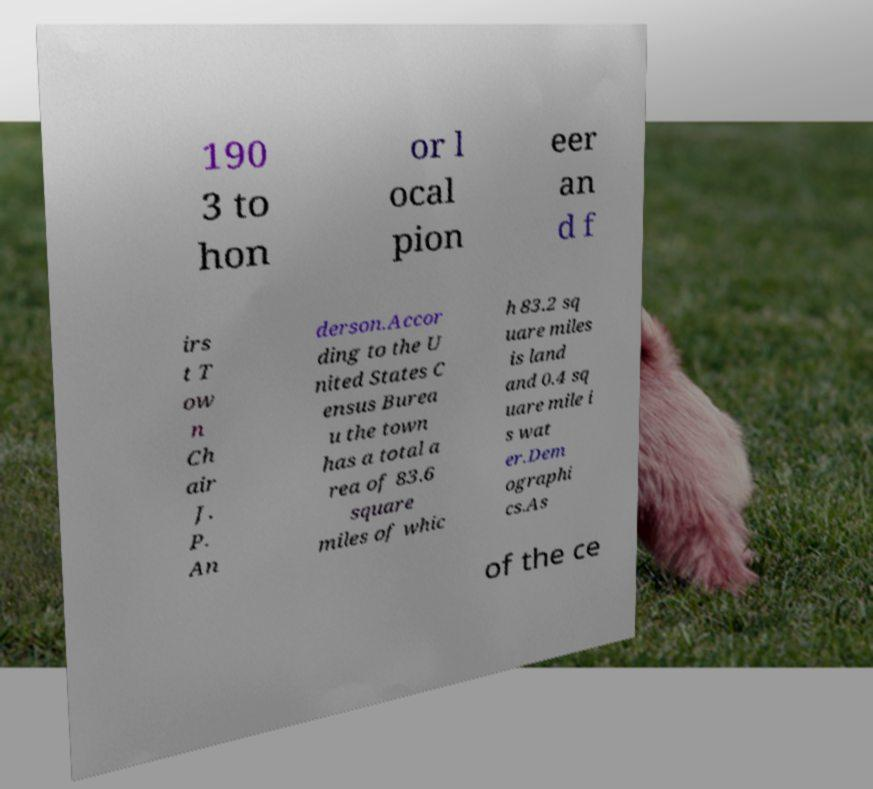Can you accurately transcribe the text from the provided image for me? 190 3 to hon or l ocal pion eer an d f irs t T ow n Ch air J. P. An derson.Accor ding to the U nited States C ensus Burea u the town has a total a rea of 83.6 square miles of whic h 83.2 sq uare miles is land and 0.4 sq uare mile i s wat er.Dem ographi cs.As of the ce 